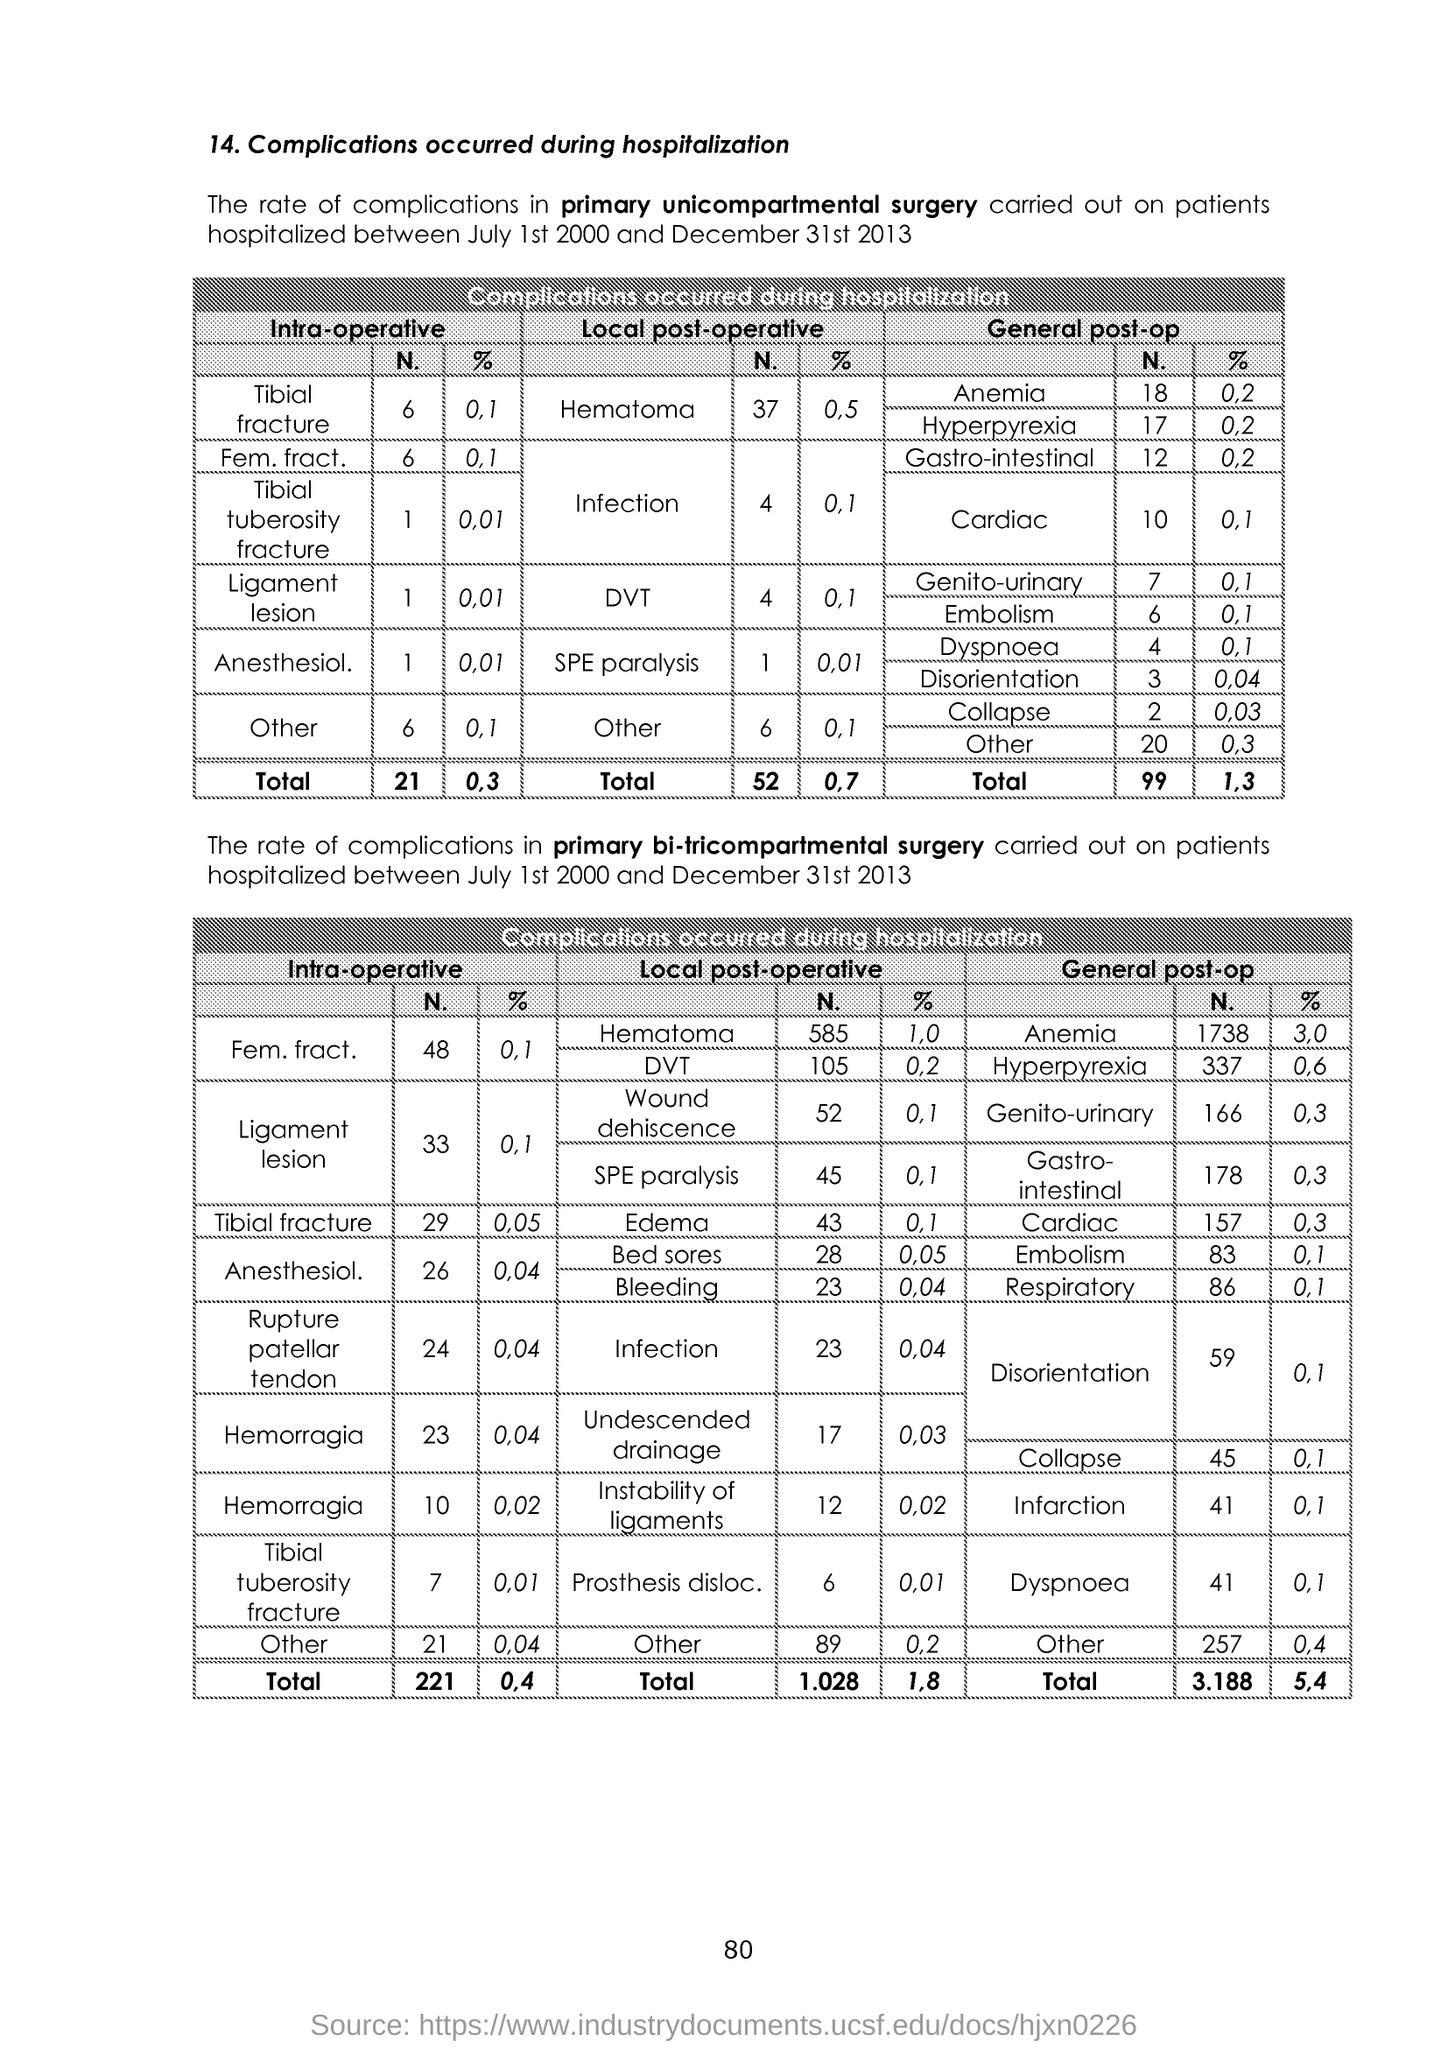What are the two tables about?
Provide a short and direct response. Complications occurred during hospitalization. What is the percentage in Anesthesiol. In Intra-operative in primary unicompartmental surgery?
Keep it short and to the point. 0.01. 